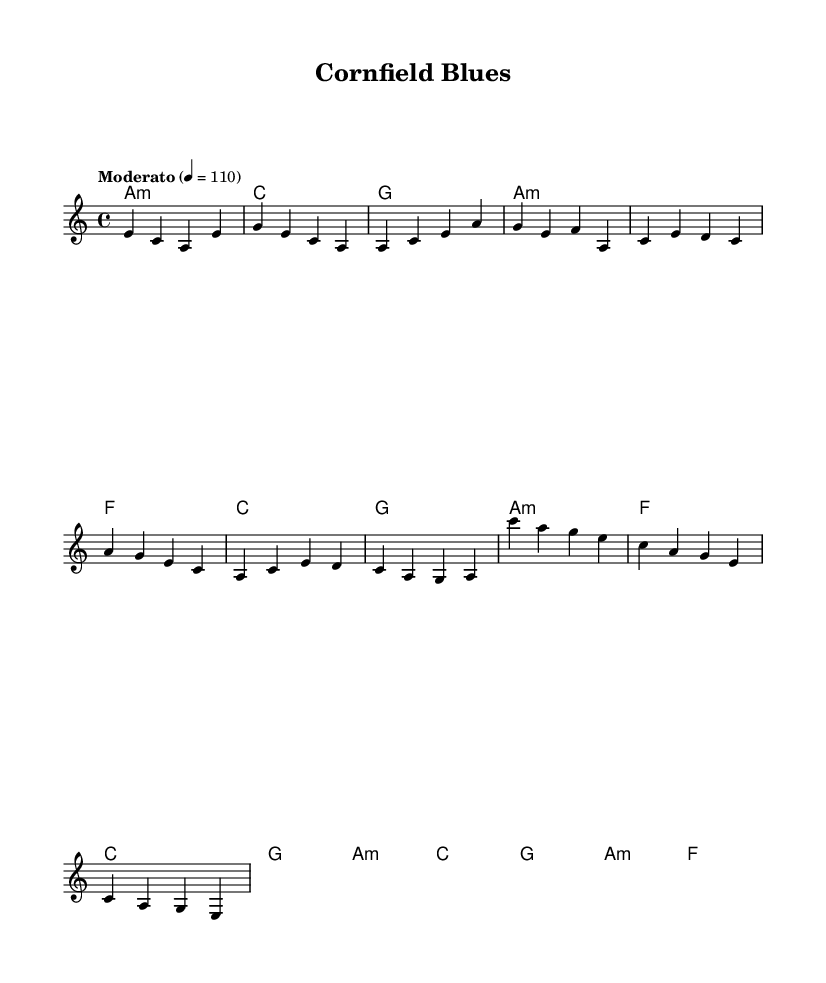What is the key signature of this music? The key signature is A minor, which has no sharps or flats. A minor is the relative minor of C major, sharing the same key signature.
Answer: A minor What is the time signature of this music? The time signature is 4/4, which means there are four beats in each measure and the quarter note receives one beat. This is a common time signature used in various musical genres.
Answer: 4/4 What is the tempo marking in this music? The tempo marking is "Moderato," which translates to a moderate speed. The specific BPM given is 110. This informs the performer of the intended pace of the piece.
Answer: Moderato How many measures are there in the chorus section? The chorus section displayed has four measures. This can be deduced by counting the individual segments between the bar lines specifically labeled for the chorus in the coding provided.
Answer: 4 What is the first chord in the intro? The first chord in the intro is an A minor chord, as indicated in the harmonies section of the code where the first measure states "a1:m." This chord establishes the mood for the piece.
Answer: A minor What kind of musical elements are fused in this piece? The musical elements in this piece are funk and country, as indicated by the genre hybrid in its title. The rhythmic groove typical of funk is combined with the melodies and harmonies commonly found in country music.
Answer: Funk and country What is the last chord in the bridge? The last chord in the bridge is an F major chord as indicated in the final measure of the bridge section. The presence of the "f" in the chord mode confirms this.
Answer: F major 